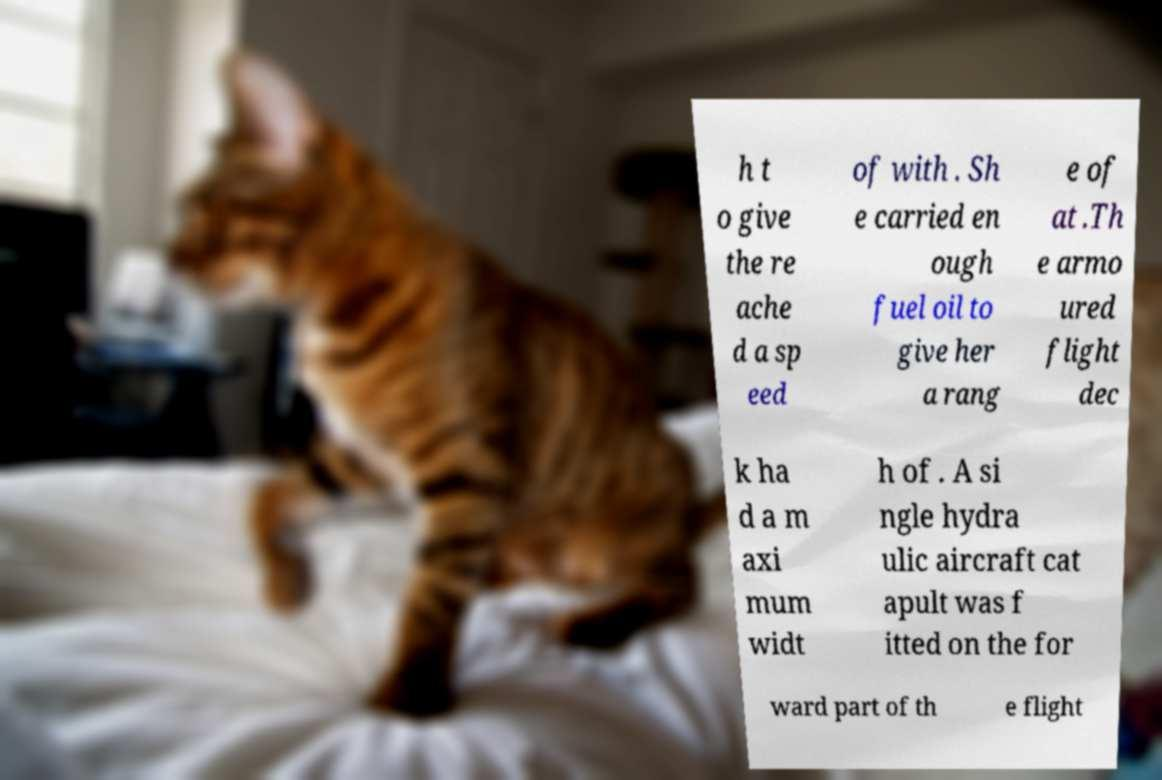I need the written content from this picture converted into text. Can you do that? h t o give the re ache d a sp eed of with . Sh e carried en ough fuel oil to give her a rang e of at .Th e armo ured flight dec k ha d a m axi mum widt h of . A si ngle hydra ulic aircraft cat apult was f itted on the for ward part of th e flight 